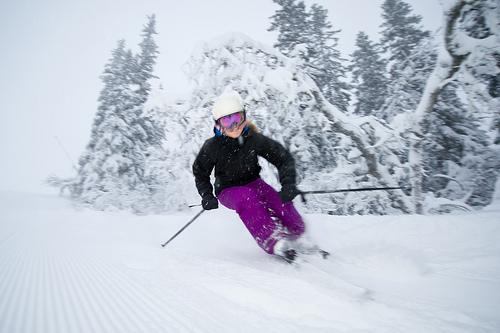Provide a brief overview of the image, focusing on the primary subject and their attire. A girl wearing a white helmet, black coat, and purple pants is skiing on a snow-covered mountain. List three pieces of skiing equipment that the young girl is wearing. The young girl is wearing a white helmet, purple goggles, and black ski gloves. Mention the dominant color of the skier's helmet, pants, and jacket. The skier's helmet is white, pants are purple, and jacket is black. Identify the main activity and the person performing it in the photo. A young girl is skiing down a snowy mountain wearing protective gear. Explain the visual in a single sentence, mentioning the main subject and their clothing. A young girl goes skiing, dressed in a white helmet, purple pants, and a black coat. Write a brief statement describing the girl's appearance as she skis. The skiing girl sports a white helmet, black coat, and purple pants in her winter attire. Express what the girl is doing in the image, along with the color of her jacket and pants. The girl is skiing, wearing a black jacket and purple pants. Summarize the action being performed and the person in the image with a few details about their clothing. A young girl, wearing a white helmet, black coat, and purple pants, is skiing down a snowy slope. Describe three important elements of the girl's attire in the picture. The girl is wearing a white helmet, a black coat, and purple pants while skiing. Indicate the main activity of the image along with a description of the subject's clothing. A young girl on skis is suited up in a white helmet, a black coat, and purple pants. 